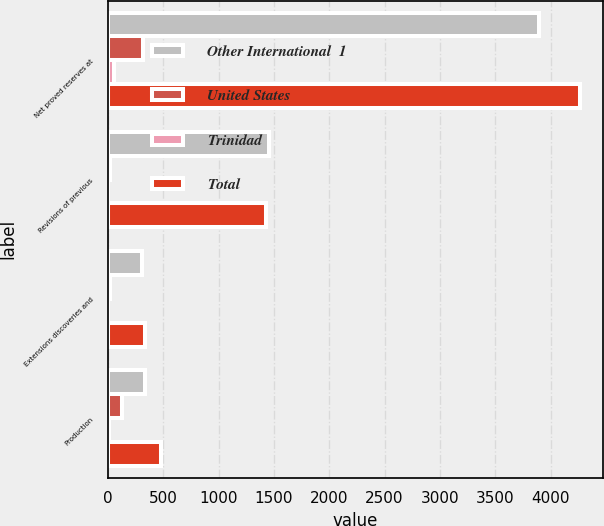Convert chart to OTSL. <chart><loc_0><loc_0><loc_500><loc_500><stacked_bar_chart><ecel><fcel>Net proved reserves at<fcel>Revisions of previous<fcel>Extensions discoveries and<fcel>Production<nl><fcel>Other International  1<fcel>3898.5<fcel>1453.1<fcel>306.3<fcel>337.3<nl><fcel>United States<fcel>313.4<fcel>16.8<fcel>21.7<fcel>127.5<nl><fcel>Trinidad<fcel>51.2<fcel>5.6<fcel>4.4<fcel>10.9<nl><fcel>Total<fcel>4263.1<fcel>1430.7<fcel>332.4<fcel>475.7<nl></chart> 